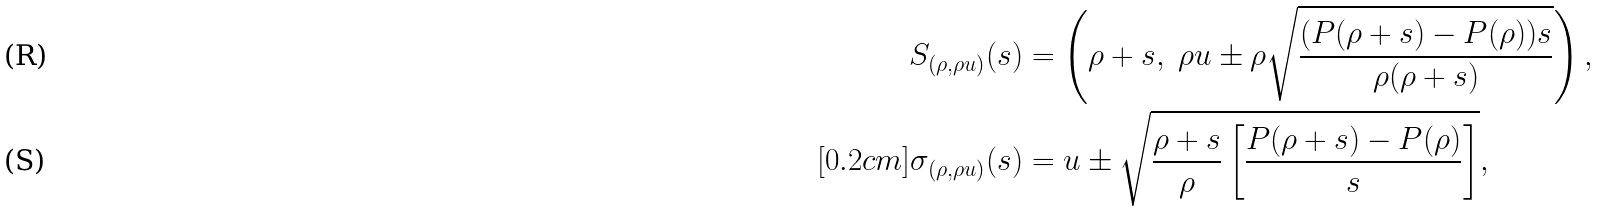Convert formula to latex. <formula><loc_0><loc_0><loc_500><loc_500>S _ { ( \rho , \rho u ) } ( s ) & = \left ( \rho + s , \ \rho u \pm \rho \sqrt { \frac { ( P ( \rho + s ) - P ( \rho ) ) s } { \rho ( \rho + s ) } } \right ) , \\ [ 0 . 2 c m ] \sigma _ { ( \rho , \rho u ) } ( s ) & = u \pm \sqrt { \frac { \rho + s } { \rho } \left [ \frac { P ( \rho + s ) - P ( \rho ) } { s } \right ] } ,</formula> 